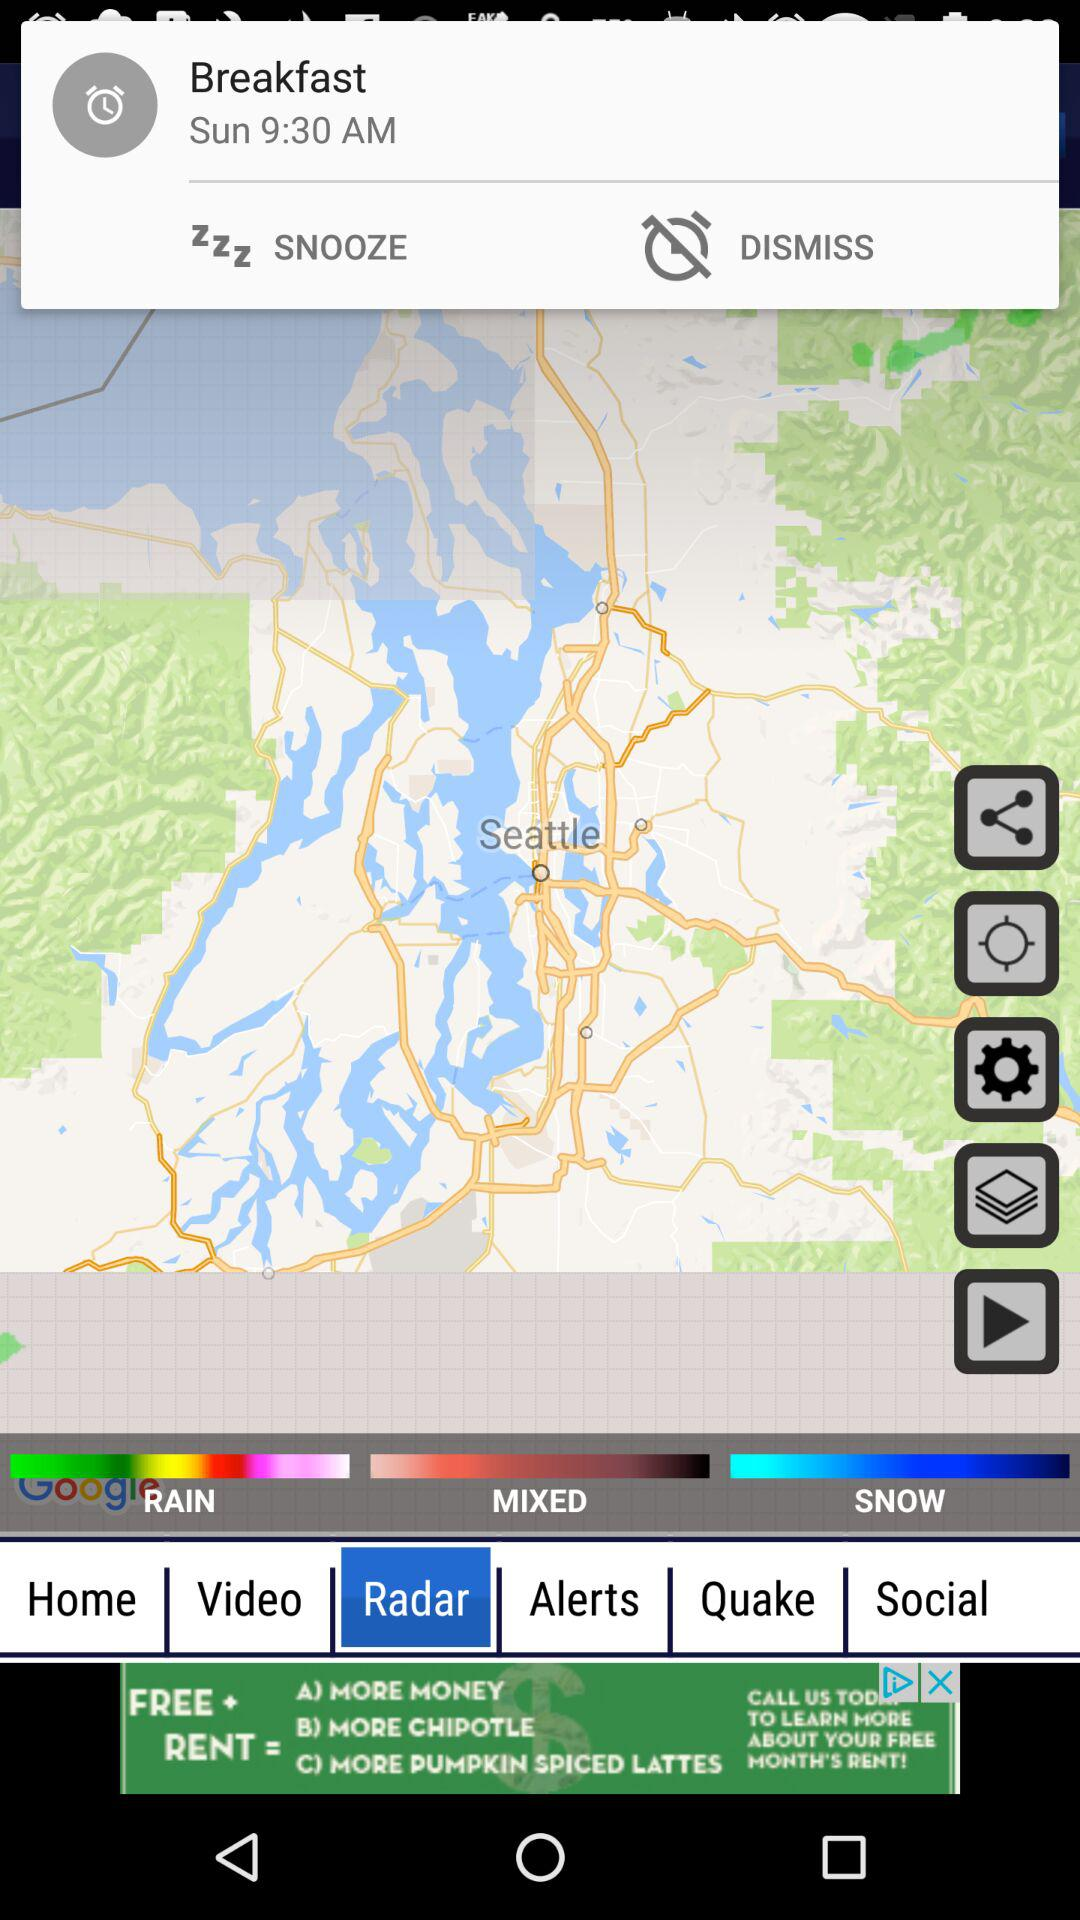How many different types of weather are currently being forecast?
Answer the question using a single word or phrase. 3 